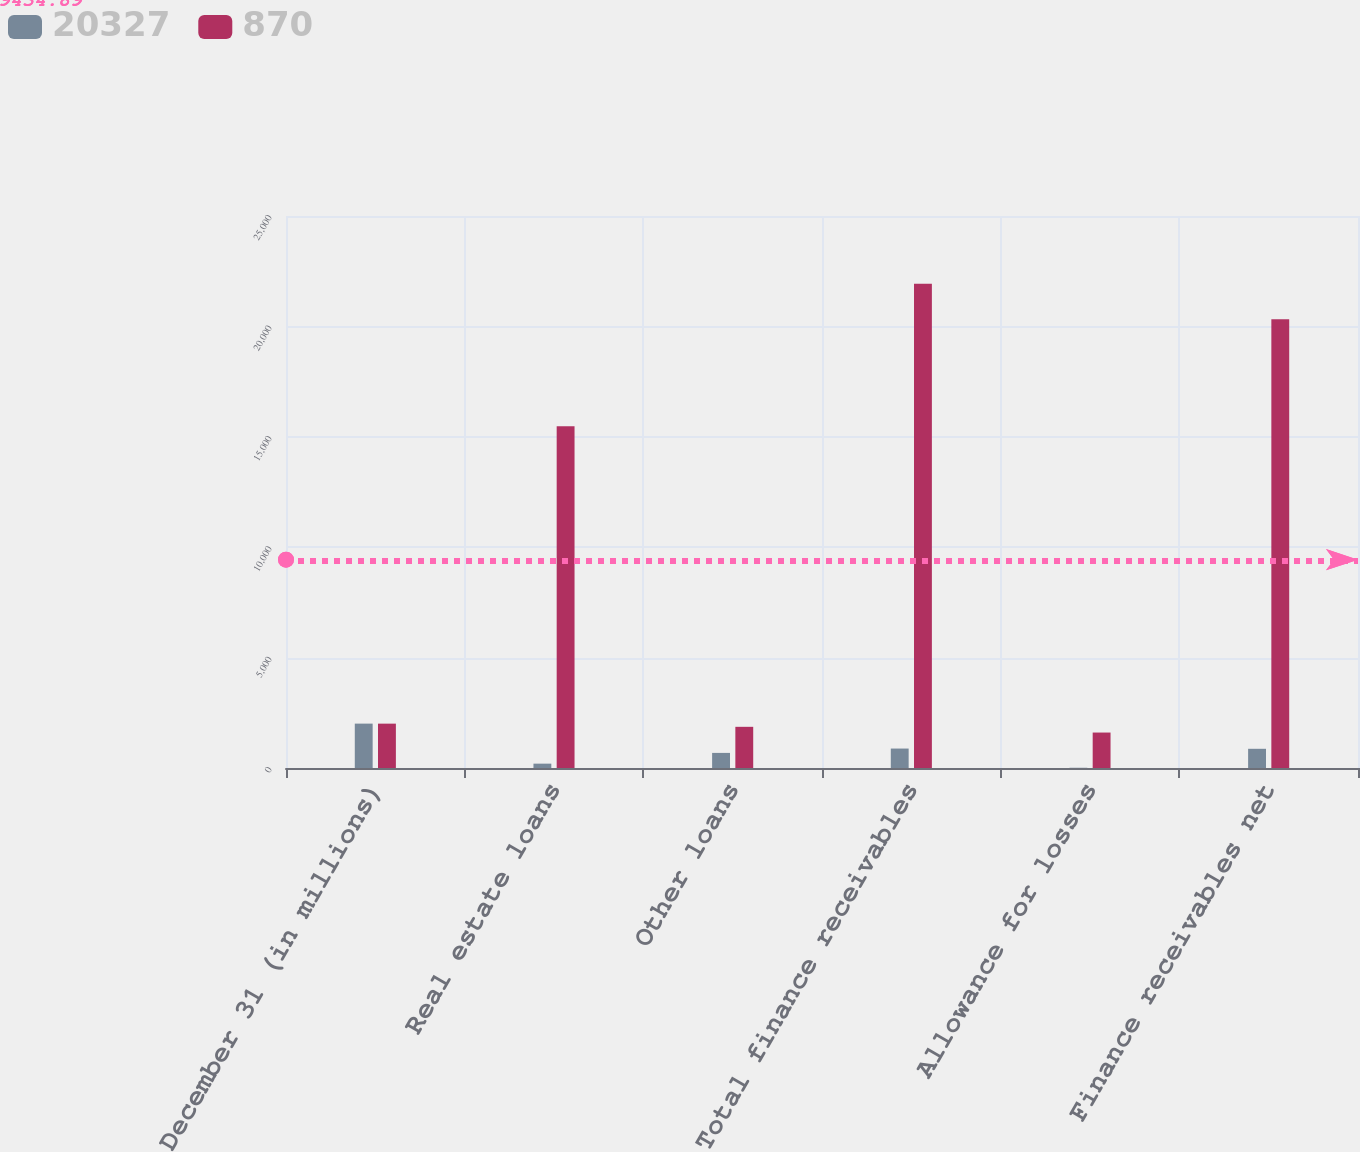Convert chart to OTSL. <chart><loc_0><loc_0><loc_500><loc_500><stacked_bar_chart><ecel><fcel>December 31 (in millions)<fcel>Real estate loans<fcel>Other loans<fcel>Total finance receivables<fcel>Allowance for losses<fcel>Finance receivables net<nl><fcel>20327<fcel>2010<fcel>197<fcel>684<fcel>881<fcel>11<fcel>870<nl><fcel>870<fcel>2009<fcel>15473<fcel>1865<fcel>21933<fcel>1606<fcel>20327<nl></chart> 